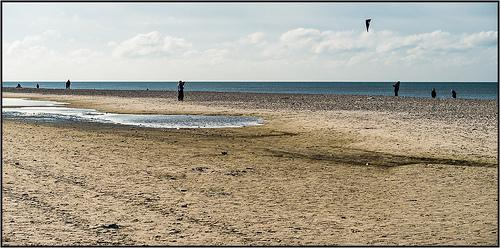Question: where is this scene?
Choices:
A. At the beach.
B. Ocean.
C. Lake.
D. Pond.
Answer with the letter. Answer: A Question: why are there clouds?
Choices:
A. Rainy.
B. Snowing.
C. Cloudy weather.
D. Thunderstorm.
Answer with the letter. Answer: C Question: what environment is this?
Choices:
A. Ocean.
B. Park.
C. Beach.
D. Zoo.
Answer with the letter. Answer: C Question: what color is the sky?
Choices:
A. Blue.
B. Grey.
C. White.
D. Purple.
Answer with the letter. Answer: A Question: what is in the sky?
Choices:
A. Clouds.
B. Plane.
C. Bird.
D. Kite.
Answer with the letter. Answer: A Question: who is present?
Choices:
A. A man.
B. A woman.
C. People.
D. A boy.
Answer with the letter. Answer: C 